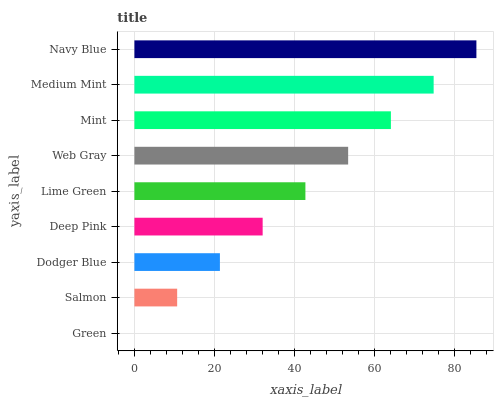Is Green the minimum?
Answer yes or no. Yes. Is Navy Blue the maximum?
Answer yes or no. Yes. Is Salmon the minimum?
Answer yes or no. No. Is Salmon the maximum?
Answer yes or no. No. Is Salmon greater than Green?
Answer yes or no. Yes. Is Green less than Salmon?
Answer yes or no. Yes. Is Green greater than Salmon?
Answer yes or no. No. Is Salmon less than Green?
Answer yes or no. No. Is Lime Green the high median?
Answer yes or no. Yes. Is Lime Green the low median?
Answer yes or no. Yes. Is Salmon the high median?
Answer yes or no. No. Is Deep Pink the low median?
Answer yes or no. No. 